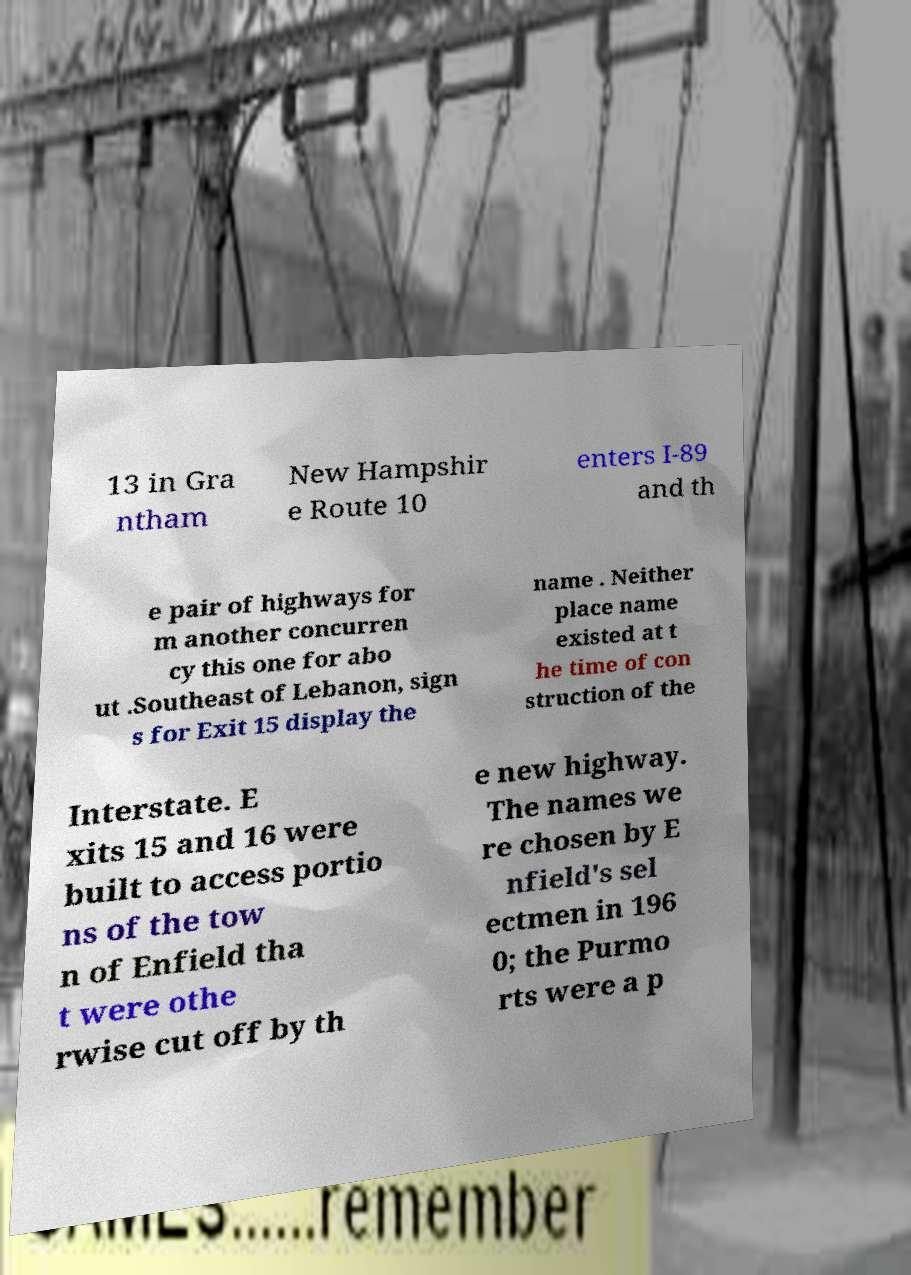There's text embedded in this image that I need extracted. Can you transcribe it verbatim? 13 in Gra ntham New Hampshir e Route 10 enters I-89 and th e pair of highways for m another concurren cy this one for abo ut .Southeast of Lebanon, sign s for Exit 15 display the name . Neither place name existed at t he time of con struction of the Interstate. E xits 15 and 16 were built to access portio ns of the tow n of Enfield tha t were othe rwise cut off by th e new highway. The names we re chosen by E nfield's sel ectmen in 196 0; the Purmo rts were a p 